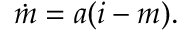<formula> <loc_0><loc_0><loc_500><loc_500>\dot { m } = a ( i - m ) .</formula> 